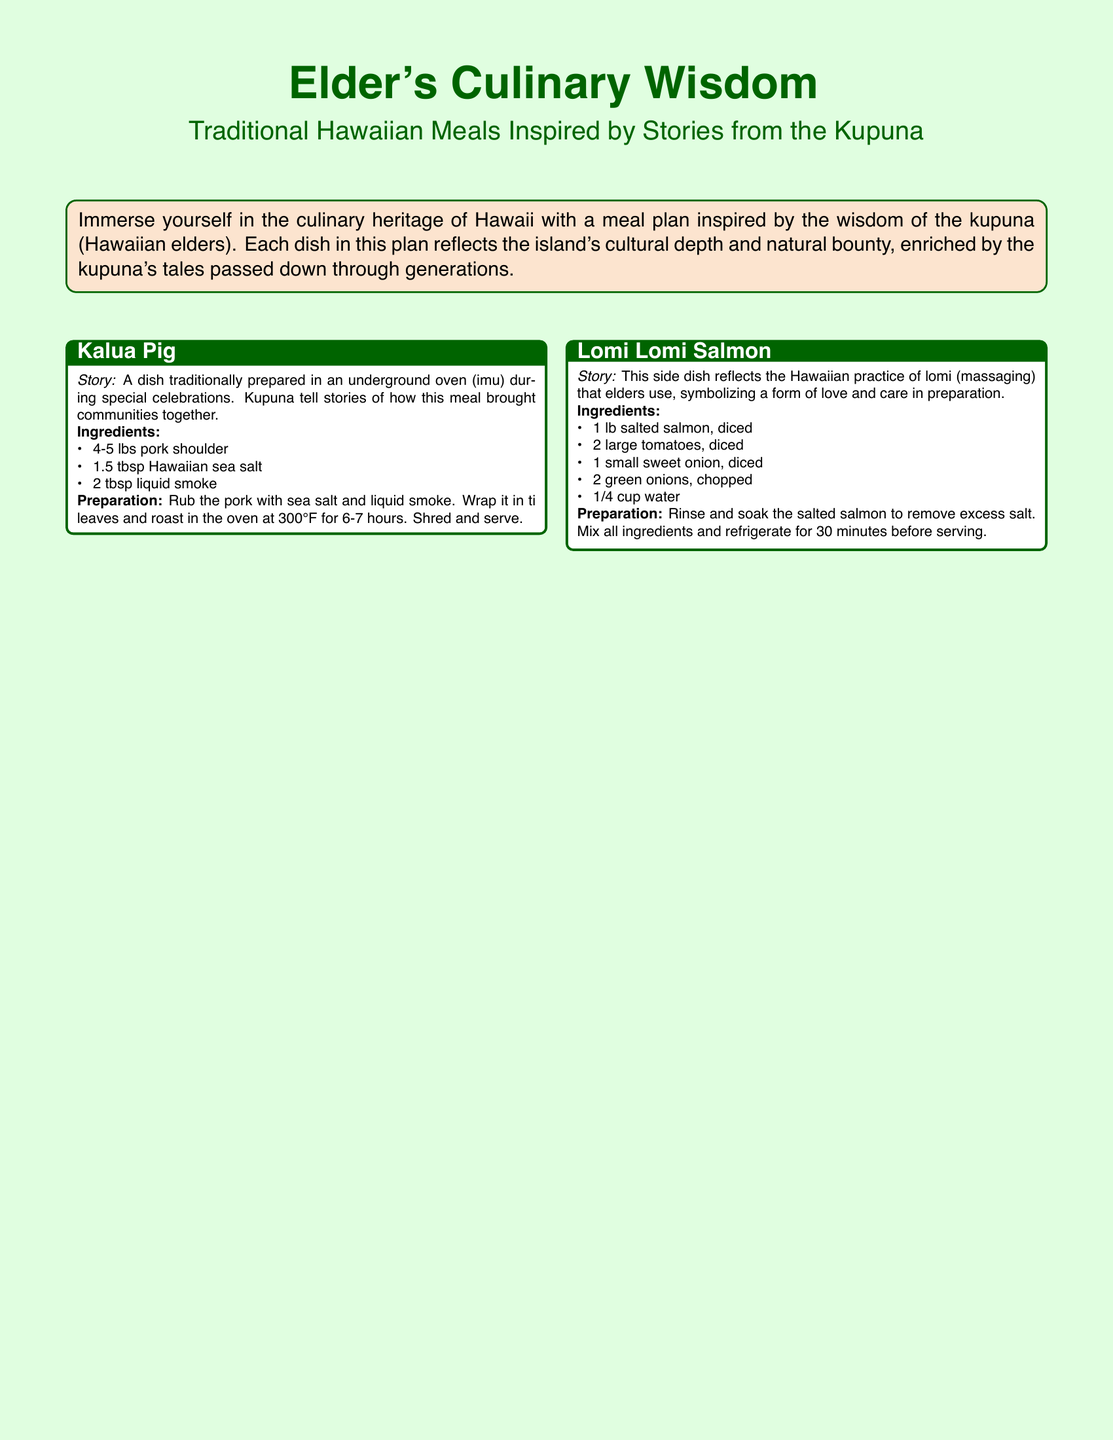what is the main theme of the document? The document focuses on the culinary heritage of Hawaii, inspired by the wisdom of the kupuna.
Answer: Elder's Culinary Wisdom how many dishes are included in the meal plan? The meal plan includes four traditional Hawaiian dishes.
Answer: Four what is the key ingredient in Kalua Pig? The key ingredient in Kalua Pig is pork shoulder.
Answer: Pork shoulder what does Lomi Lomi Salmon symbolize in Hawaiian culture? Lomi Lomi Salmon symbolizes love and care in preparation.
Answer: Love and care what is the main ingredient used to make Poi? The main ingredient used to make Poi is taro root.
Answer: Taro root how long should Kalua Pig be roasted? Kalua Pig should be roasted for 6-7 hours.
Answer: 6-7 hours what type of dessert is Haupia? Haupia is a traditional coconut milk dessert.
Answer: Coconut milk dessert which dish represents a form of community gathering? Kalua Pig represents a form of community gathering.
Answer: Kalua Pig 